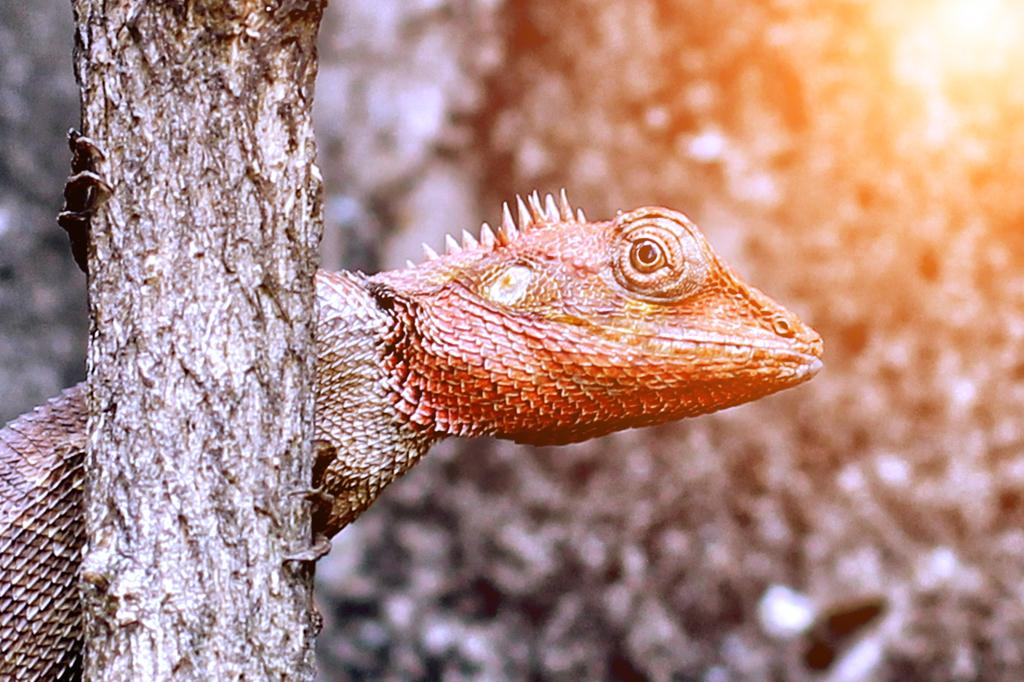What type of animal is present in the image? There is a reptile in the image. What other object can be seen in the image besides the reptile? There is a tree trunk in the image. What type of advertisement can be seen on the tree trunk in the image? There is no advertisement present on the tree trunk in the image. What type of wave can be seen in the image? There is no wave present in the image. 